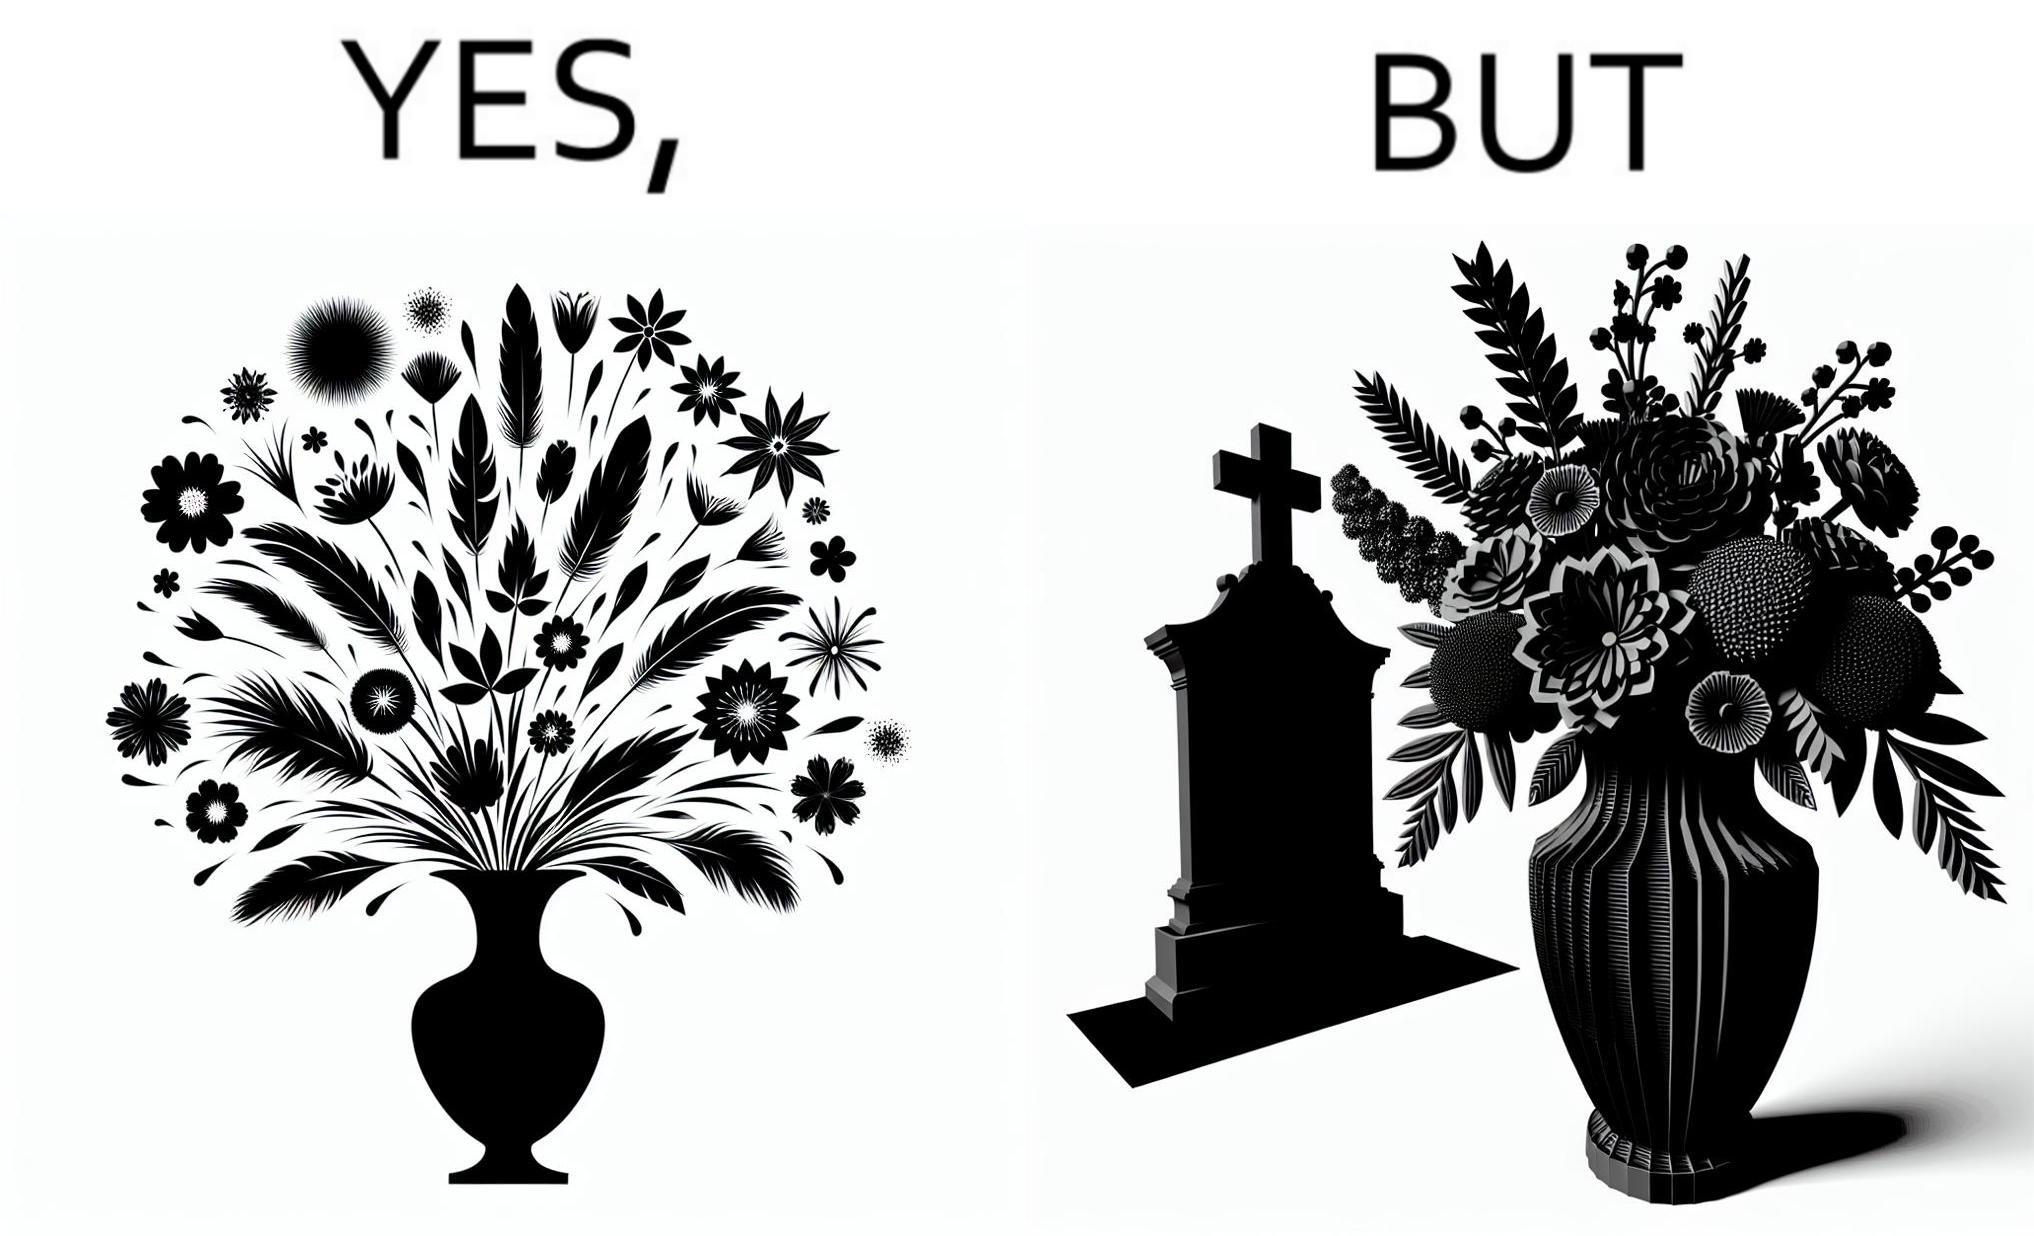Is there satirical content in this image? Yes, this image is satirical. 